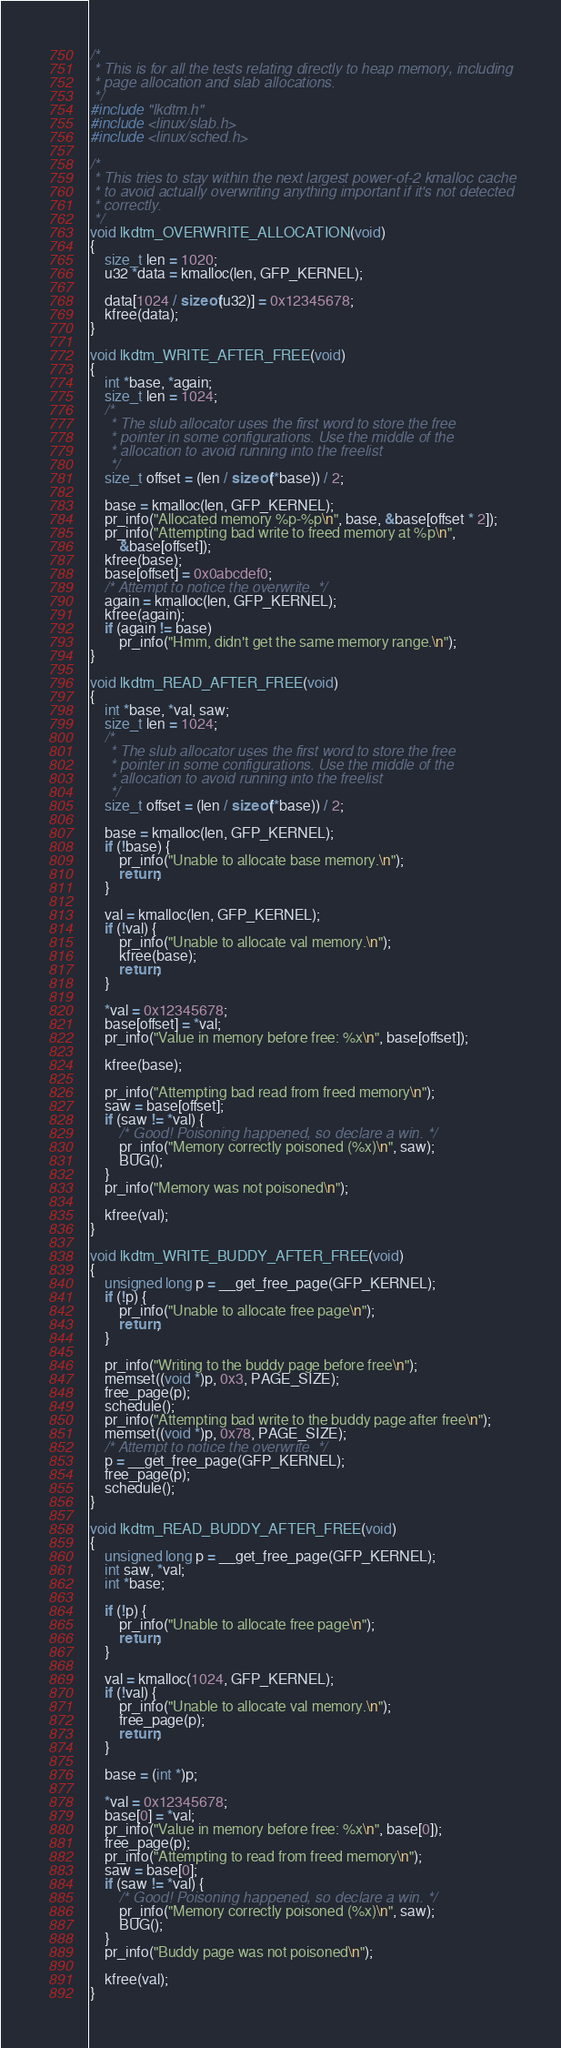Convert code to text. <code><loc_0><loc_0><loc_500><loc_500><_C_>/*
 * This is for all the tests relating directly to heap memory, including
 * page allocation and slab allocations.
 */
#include "lkdtm.h"
#include <linux/slab.h>
#include <linux/sched.h>

/*
 * This tries to stay within the next largest power-of-2 kmalloc cache
 * to avoid actually overwriting anything important if it's not detected
 * correctly.
 */
void lkdtm_OVERWRITE_ALLOCATION(void)
{
	size_t len = 1020;
	u32 *data = kmalloc(len, GFP_KERNEL);

	data[1024 / sizeof(u32)] = 0x12345678;
	kfree(data);
}

void lkdtm_WRITE_AFTER_FREE(void)
{
	int *base, *again;
	size_t len = 1024;
	/*
	 * The slub allocator uses the first word to store the free
	 * pointer in some configurations. Use the middle of the
	 * allocation to avoid running into the freelist
	 */
	size_t offset = (len / sizeof(*base)) / 2;

	base = kmalloc(len, GFP_KERNEL);
	pr_info("Allocated memory %p-%p\n", base, &base[offset * 2]);
	pr_info("Attempting bad write to freed memory at %p\n",
		&base[offset]);
	kfree(base);
	base[offset] = 0x0abcdef0;
	/* Attempt to notice the overwrite. */
	again = kmalloc(len, GFP_KERNEL);
	kfree(again);
	if (again != base)
		pr_info("Hmm, didn't get the same memory range.\n");
}

void lkdtm_READ_AFTER_FREE(void)
{
	int *base, *val, saw;
	size_t len = 1024;
	/*
	 * The slub allocator uses the first word to store the free
	 * pointer in some configurations. Use the middle of the
	 * allocation to avoid running into the freelist
	 */
	size_t offset = (len / sizeof(*base)) / 2;

	base = kmalloc(len, GFP_KERNEL);
	if (!base) {
		pr_info("Unable to allocate base memory.\n");
		return;
	}

	val = kmalloc(len, GFP_KERNEL);
	if (!val) {
		pr_info("Unable to allocate val memory.\n");
		kfree(base);
		return;
	}

	*val = 0x12345678;
	base[offset] = *val;
	pr_info("Value in memory before free: %x\n", base[offset]);

	kfree(base);

	pr_info("Attempting bad read from freed memory\n");
	saw = base[offset];
	if (saw != *val) {
		/* Good! Poisoning happened, so declare a win. */
		pr_info("Memory correctly poisoned (%x)\n", saw);
		BUG();
	}
	pr_info("Memory was not poisoned\n");

	kfree(val);
}

void lkdtm_WRITE_BUDDY_AFTER_FREE(void)
{
	unsigned long p = __get_free_page(GFP_KERNEL);
	if (!p) {
		pr_info("Unable to allocate free page\n");
		return;
	}

	pr_info("Writing to the buddy page before free\n");
	memset((void *)p, 0x3, PAGE_SIZE);
	free_page(p);
	schedule();
	pr_info("Attempting bad write to the buddy page after free\n");
	memset((void *)p, 0x78, PAGE_SIZE);
	/* Attempt to notice the overwrite. */
	p = __get_free_page(GFP_KERNEL);
	free_page(p);
	schedule();
}

void lkdtm_READ_BUDDY_AFTER_FREE(void)
{
	unsigned long p = __get_free_page(GFP_KERNEL);
	int saw, *val;
	int *base;

	if (!p) {
		pr_info("Unable to allocate free page\n");
		return;
	}

	val = kmalloc(1024, GFP_KERNEL);
	if (!val) {
		pr_info("Unable to allocate val memory.\n");
		free_page(p);
		return;
	}

	base = (int *)p;

	*val = 0x12345678;
	base[0] = *val;
	pr_info("Value in memory before free: %x\n", base[0]);
	free_page(p);
	pr_info("Attempting to read from freed memory\n");
	saw = base[0];
	if (saw != *val) {
		/* Good! Poisoning happened, so declare a win. */
		pr_info("Memory correctly poisoned (%x)\n", saw);
		BUG();
	}
	pr_info("Buddy page was not poisoned\n");

	kfree(val);
}
</code> 